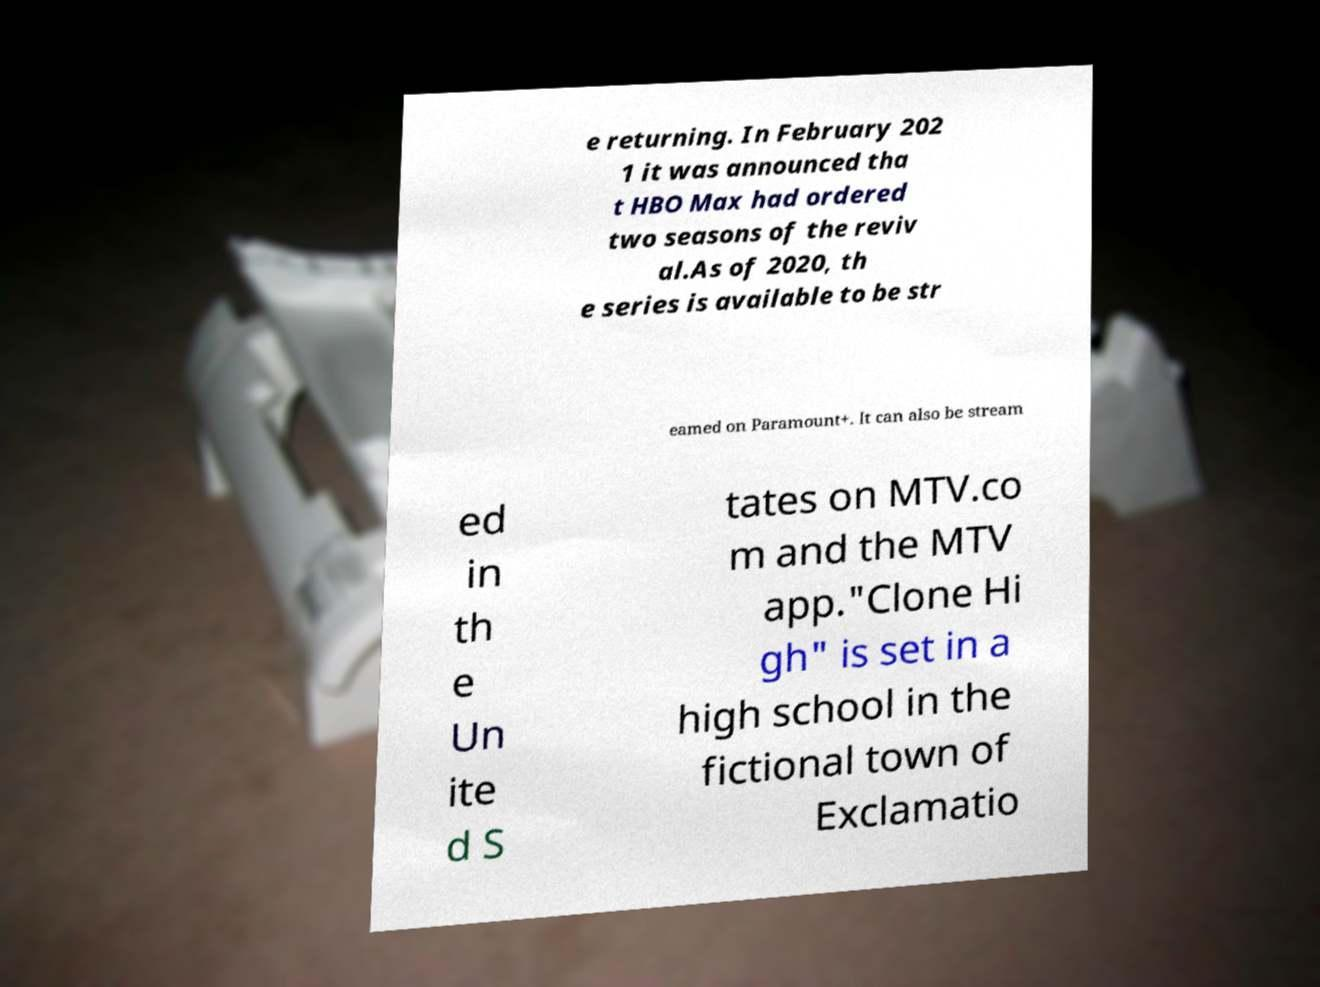Please read and relay the text visible in this image. What does it say? e returning. In February 202 1 it was announced tha t HBO Max had ordered two seasons of the reviv al.As of 2020, th e series is available to be str eamed on Paramount+. It can also be stream ed in th e Un ite d S tates on MTV.co m and the MTV app."Clone Hi gh" is set in a high school in the fictional town of Exclamatio 